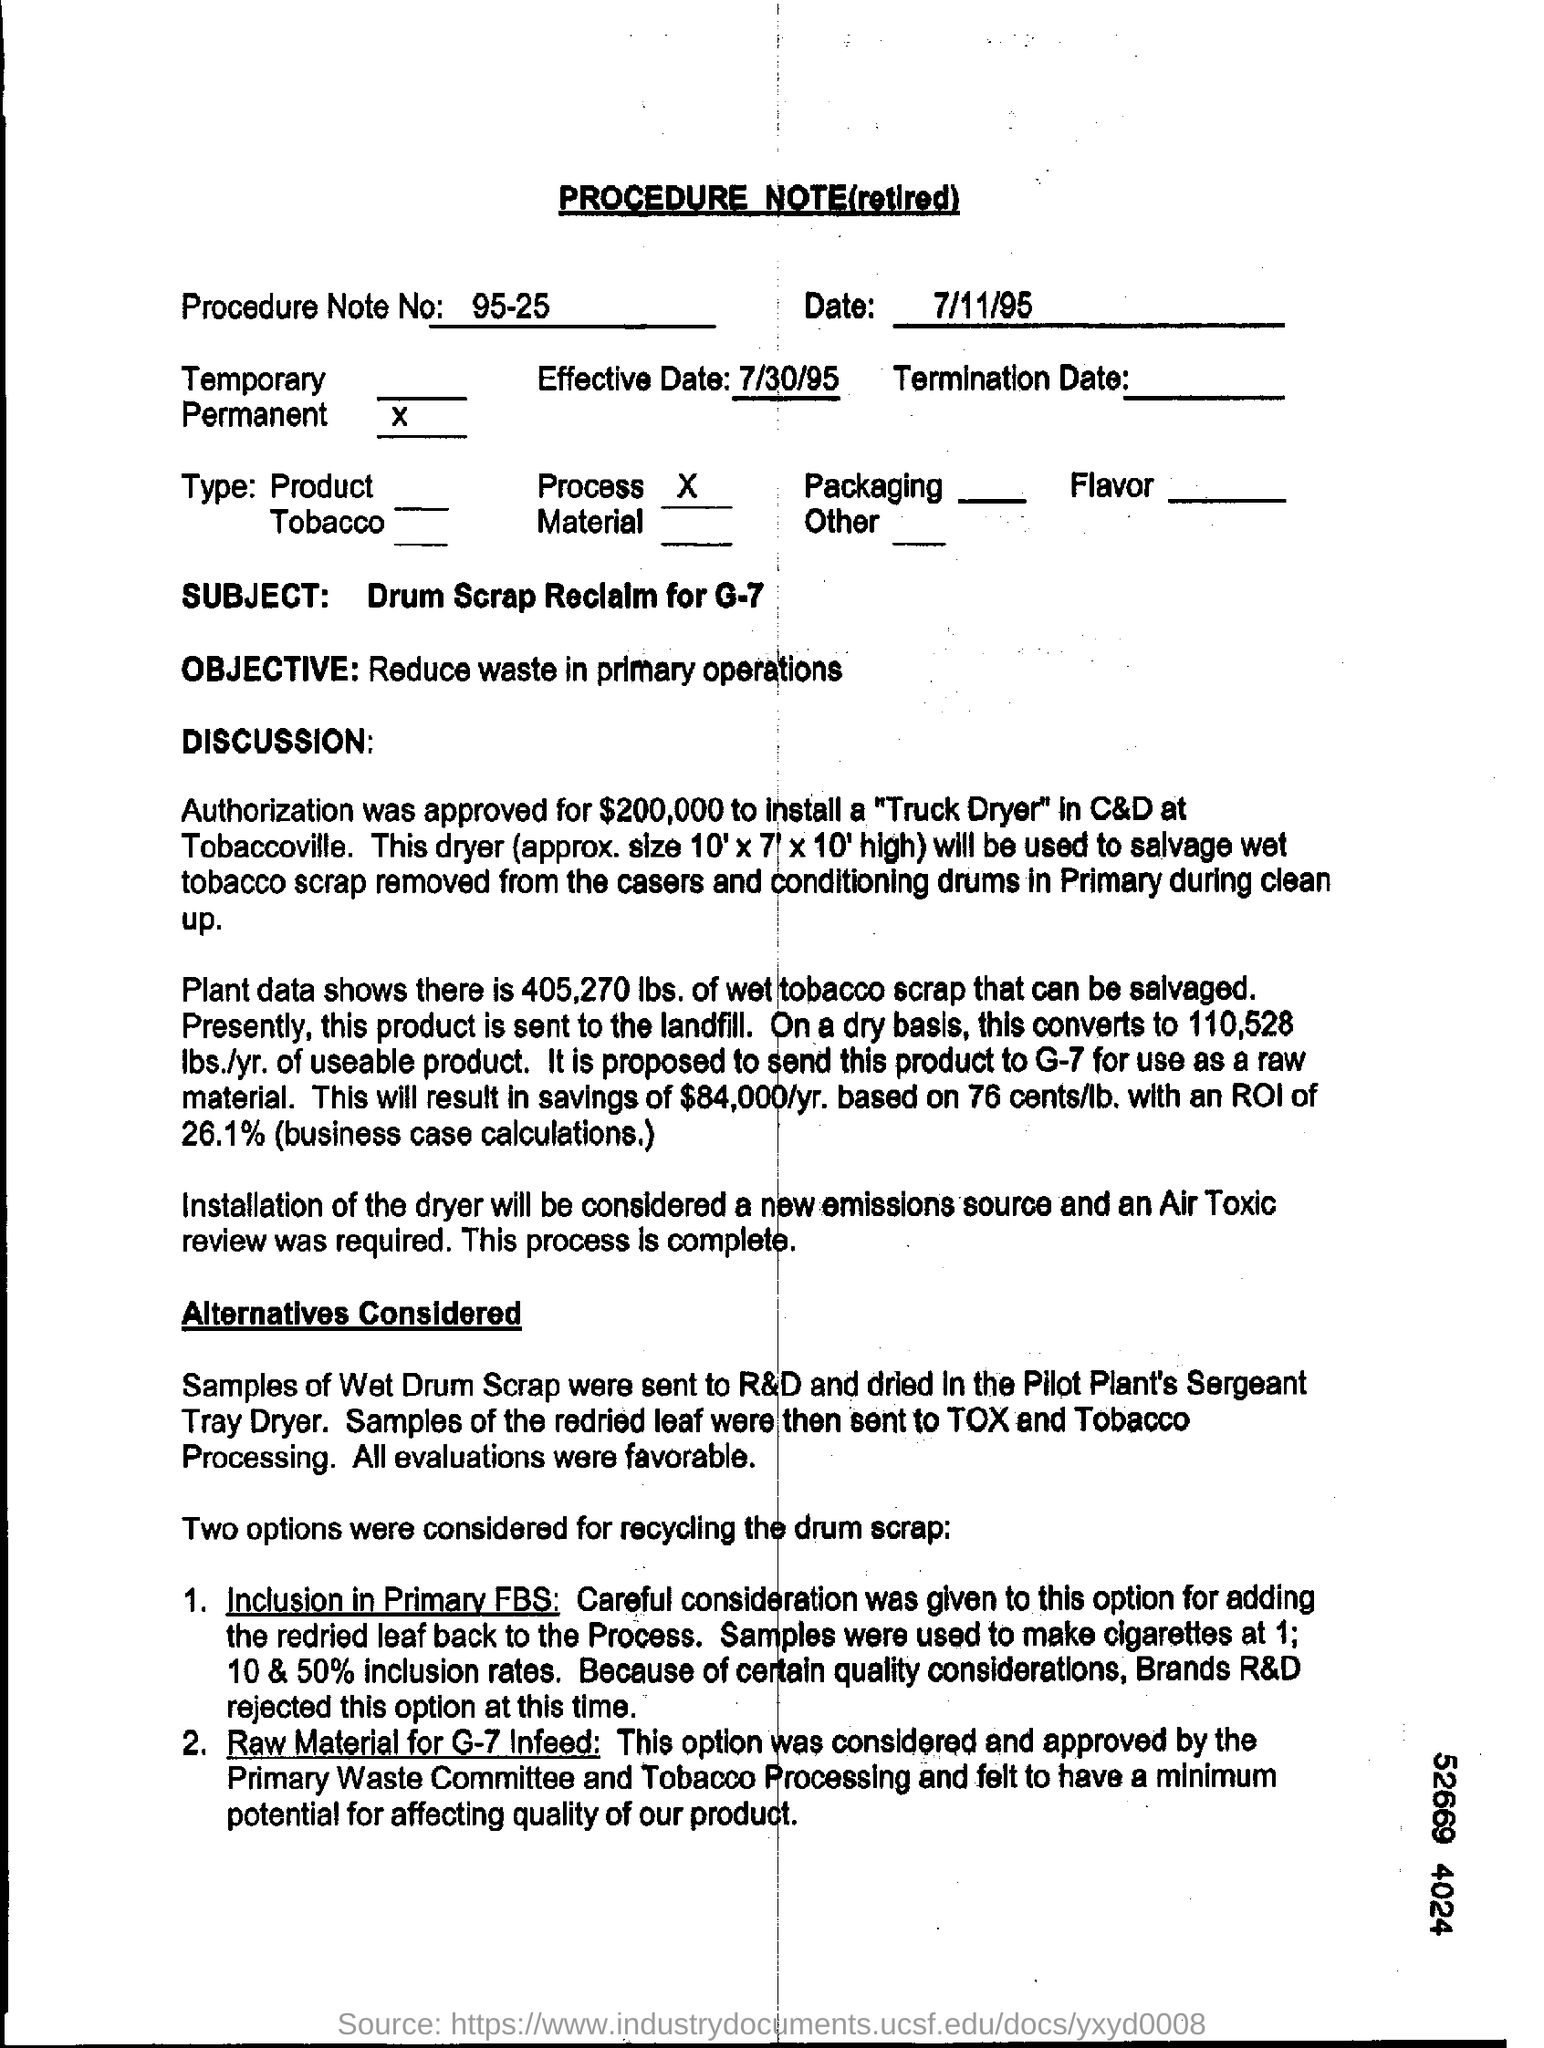Specify some key components in this picture. This is a Procedure Note (retired). The given document has a Procedure Note No of 95-25. The objective, as stated in the document, is to reduce waste in primary operations. The effective date mentioned in the procedure note is July 30, 1995. Based on the plant data, the estimated amount of wet tobacco scrap that can be salvaged is 405,270 pounds. 